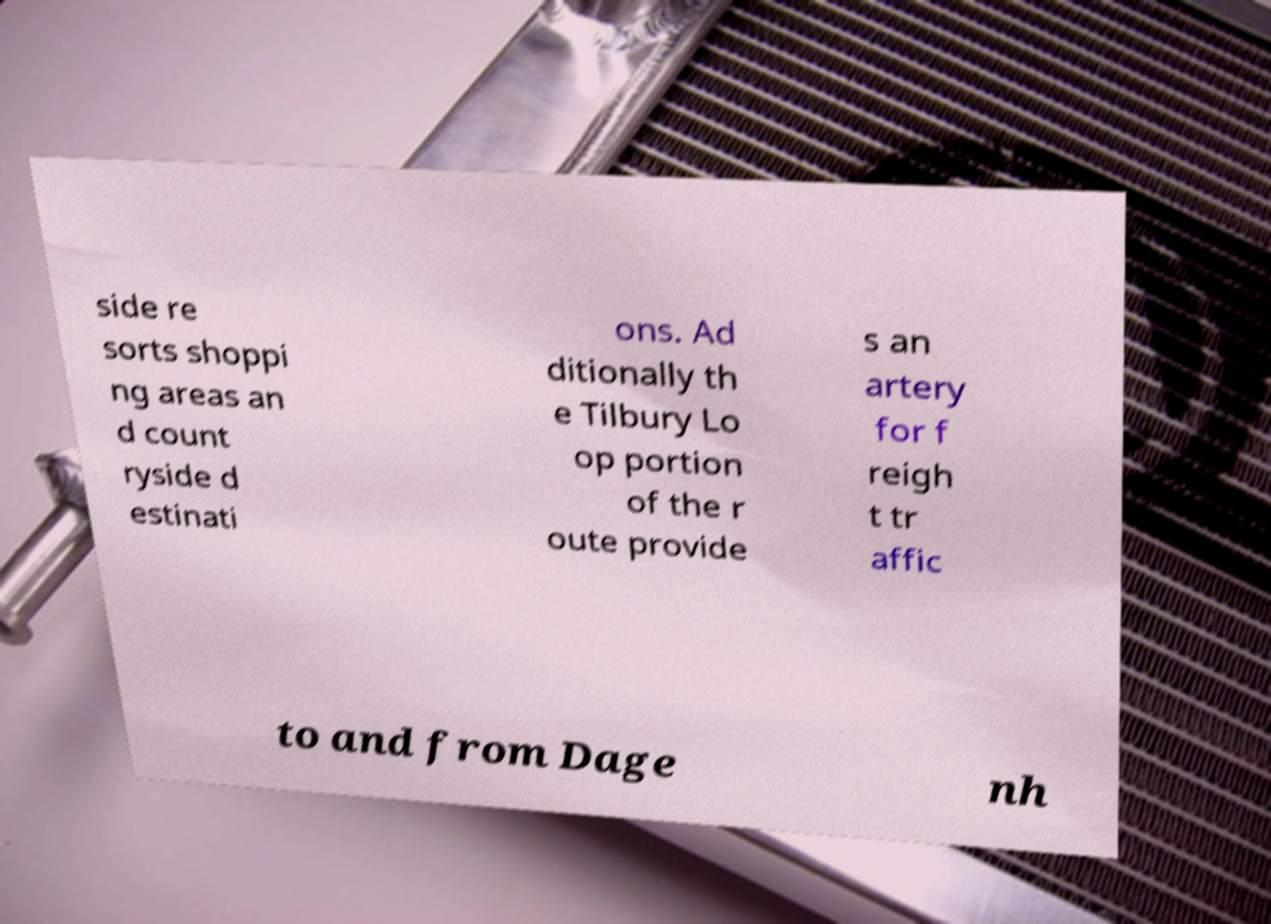Could you assist in decoding the text presented in this image and type it out clearly? side re sorts shoppi ng areas an d count ryside d estinati ons. Ad ditionally th e Tilbury Lo op portion of the r oute provide s an artery for f reigh t tr affic to and from Dage nh 